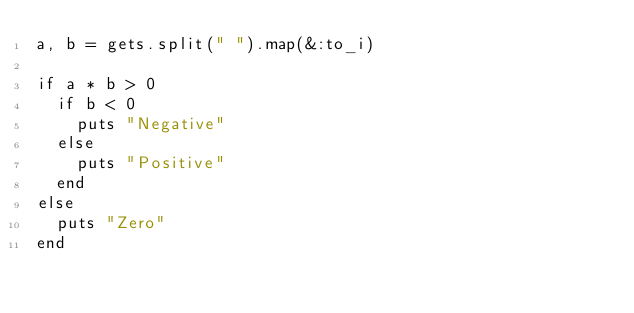<code> <loc_0><loc_0><loc_500><loc_500><_Ruby_>a, b = gets.split(" ").map(&:to_i)

if a * b > 0
  if b < 0
    puts "Negative"
  else
    puts "Positive"
  end
else
  puts "Zero"
end
</code> 